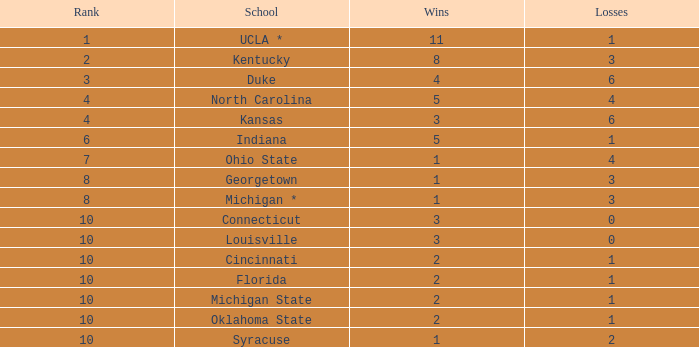Tell me the average Rank for lossess less than 6 and wins less than 11 for michigan state 10.0. 